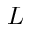Convert formula to latex. <formula><loc_0><loc_0><loc_500><loc_500>L</formula> 